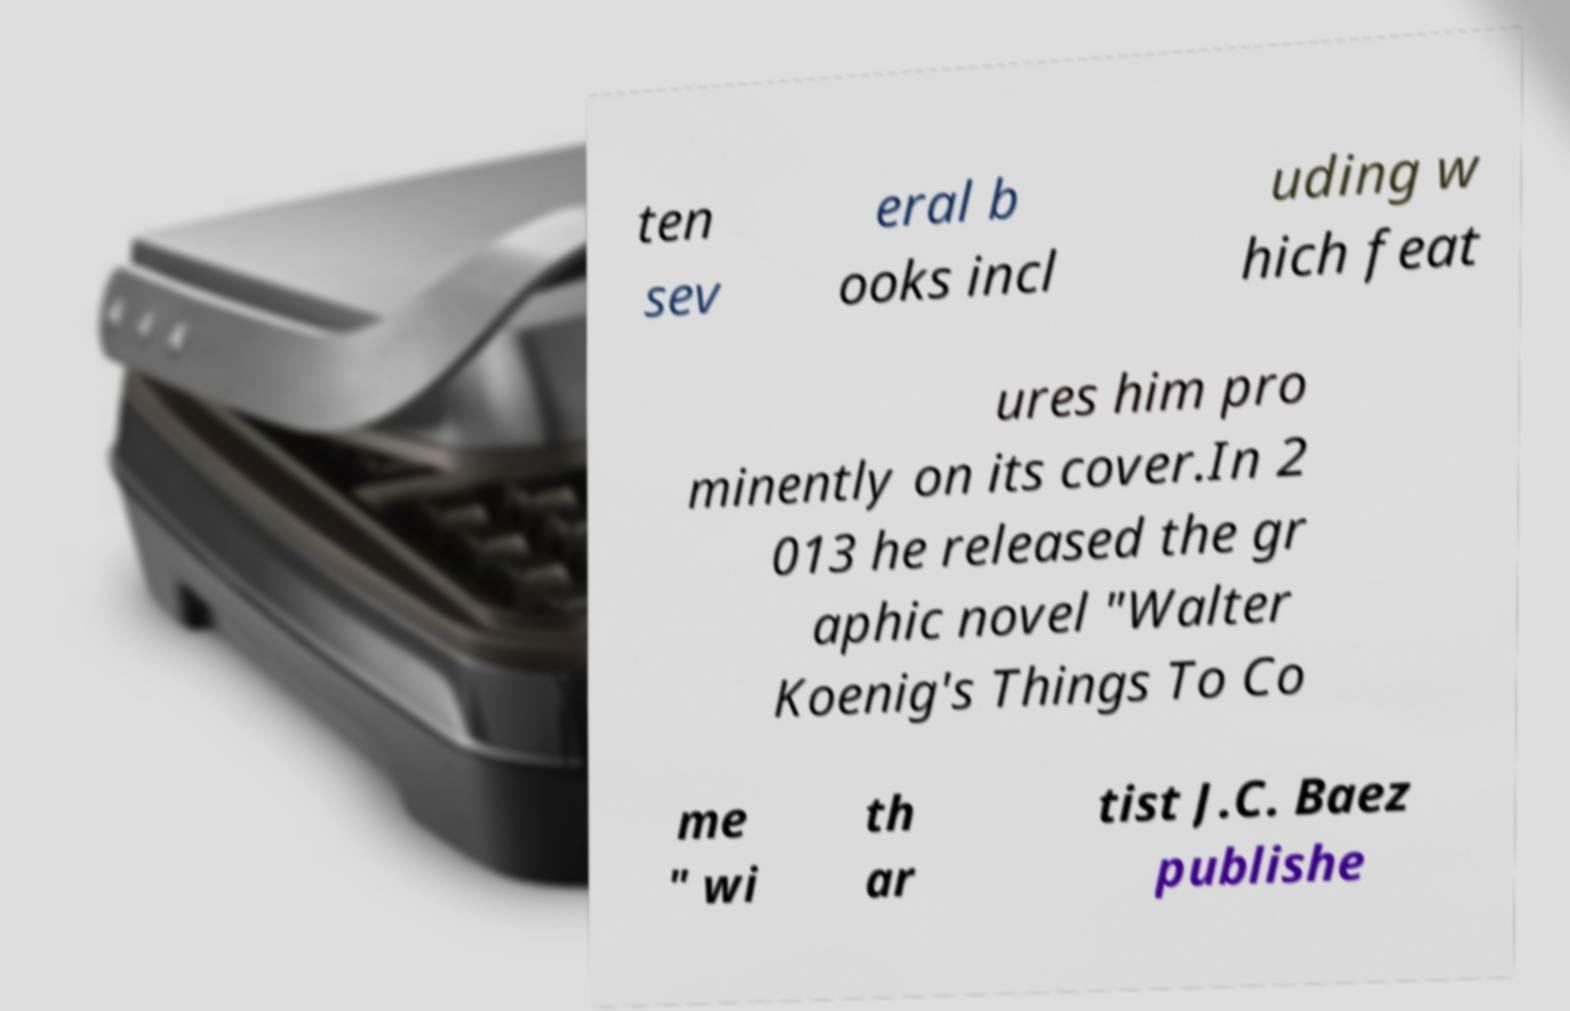Please identify and transcribe the text found in this image. ten sev eral b ooks incl uding w hich feat ures him pro minently on its cover.In 2 013 he released the gr aphic novel "Walter Koenig's Things To Co me " wi th ar tist J.C. Baez publishe 